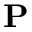<formula> <loc_0><loc_0><loc_500><loc_500>P</formula> 